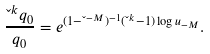<formula> <loc_0><loc_0><loc_500><loc_500>\frac { \L ^ { k } q _ { 0 } } { q _ { 0 } } = e ^ { ( 1 - \L ^ { - M } ) ^ { - 1 } ( \L ^ { k } - 1 ) \log u _ { - M } } .</formula> 